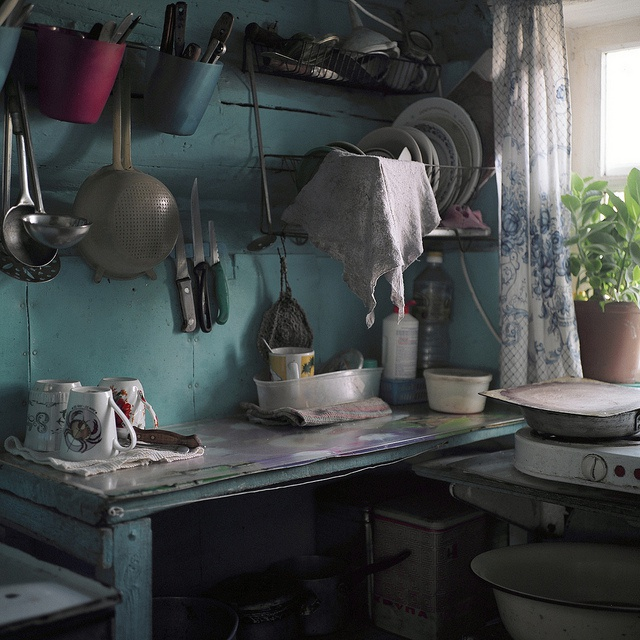Describe the objects in this image and their specific colors. I can see potted plant in black, gray, olive, and darkgray tones, cup in black, gray, darkgray, and lightgray tones, bowl in black, gray, darkgray, and lightgray tones, bottle in black and gray tones, and spoon in black, gray, darkgray, and white tones in this image. 